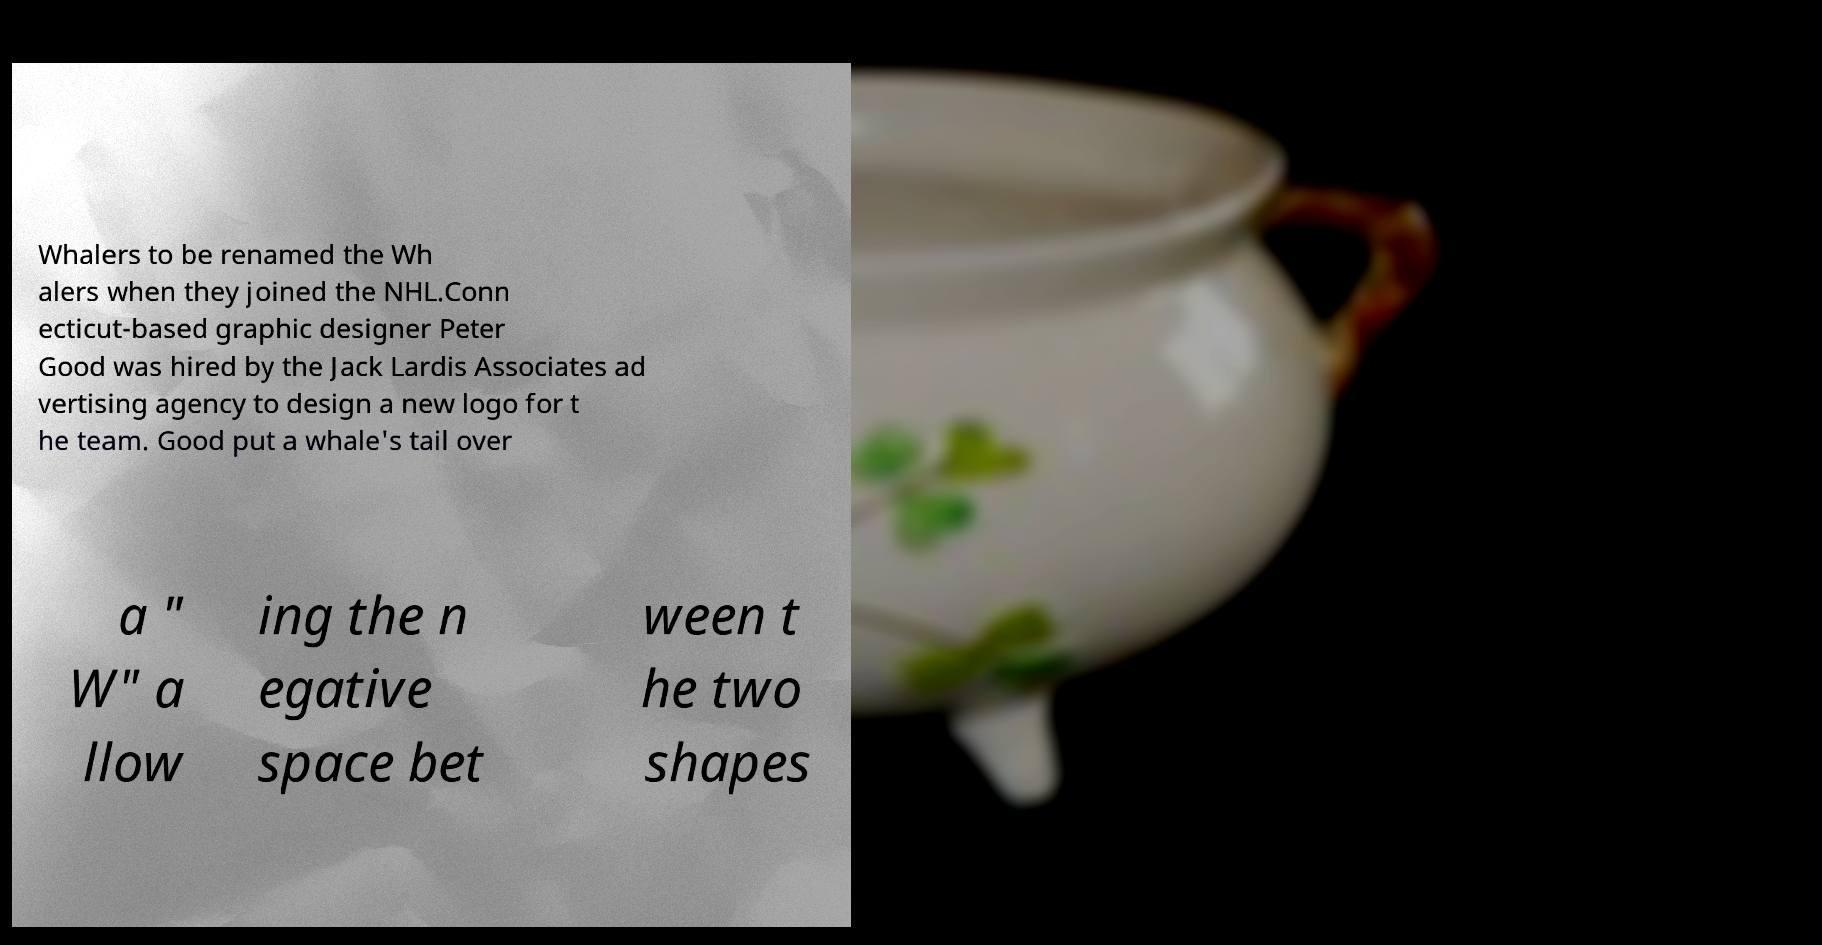There's text embedded in this image that I need extracted. Can you transcribe it verbatim? Whalers to be renamed the Wh alers when they joined the NHL.Conn ecticut-based graphic designer Peter Good was hired by the Jack Lardis Associates ad vertising agency to design a new logo for t he team. Good put a whale's tail over a " W" a llow ing the n egative space bet ween t he two shapes 